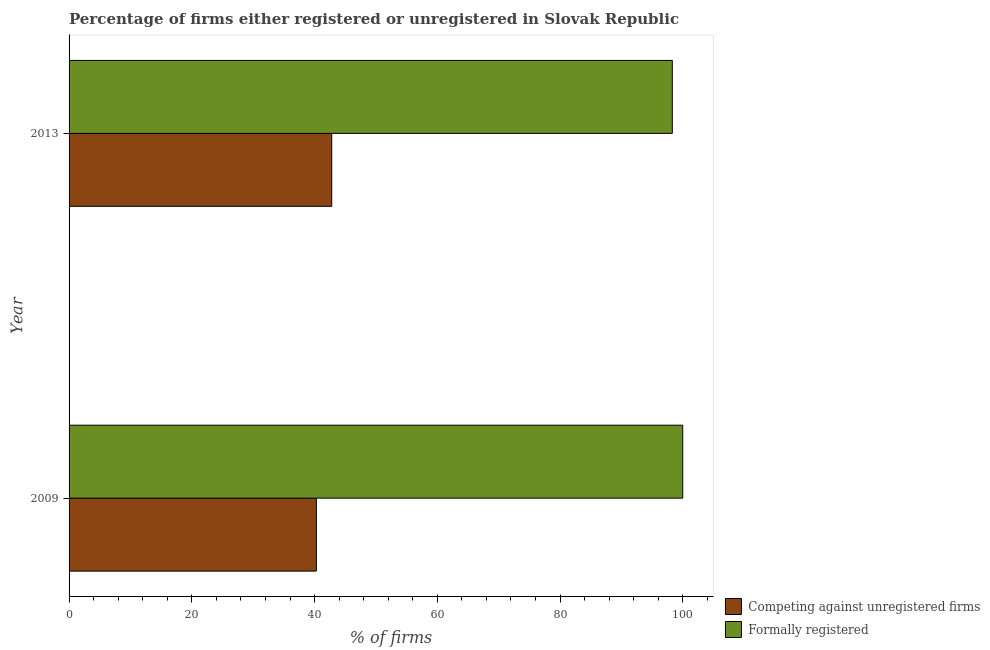How many different coloured bars are there?
Give a very brief answer. 2. How many groups of bars are there?
Offer a terse response. 2. In how many cases, is the number of bars for a given year not equal to the number of legend labels?
Provide a succinct answer. 0. What is the percentage of formally registered firms in 2009?
Your answer should be compact. 100. Across all years, what is the maximum percentage of formally registered firms?
Your response must be concise. 100. Across all years, what is the minimum percentage of formally registered firms?
Make the answer very short. 98.3. In which year was the percentage of registered firms maximum?
Ensure brevity in your answer.  2013. In which year was the percentage of registered firms minimum?
Keep it short and to the point. 2009. What is the total percentage of registered firms in the graph?
Your answer should be very brief. 83.1. What is the difference between the percentage of registered firms in 2009 and the percentage of formally registered firms in 2013?
Your answer should be compact. -58. What is the average percentage of formally registered firms per year?
Your answer should be compact. 99.15. In the year 2013, what is the difference between the percentage of registered firms and percentage of formally registered firms?
Your response must be concise. -55.5. Is the percentage of formally registered firms in 2009 less than that in 2013?
Your answer should be very brief. No. What does the 2nd bar from the top in 2009 represents?
Your answer should be compact. Competing against unregistered firms. What does the 1st bar from the bottom in 2009 represents?
Provide a short and direct response. Competing against unregistered firms. How many bars are there?
Ensure brevity in your answer.  4. Are all the bars in the graph horizontal?
Your answer should be compact. Yes. How many years are there in the graph?
Provide a succinct answer. 2. Are the values on the major ticks of X-axis written in scientific E-notation?
Your answer should be very brief. No. Does the graph contain any zero values?
Ensure brevity in your answer.  No. Does the graph contain grids?
Your answer should be compact. No. How many legend labels are there?
Offer a terse response. 2. How are the legend labels stacked?
Ensure brevity in your answer.  Vertical. What is the title of the graph?
Your answer should be very brief. Percentage of firms either registered or unregistered in Slovak Republic. Does "Forest" appear as one of the legend labels in the graph?
Provide a short and direct response. No. What is the label or title of the X-axis?
Make the answer very short. % of firms. What is the label or title of the Y-axis?
Provide a short and direct response. Year. What is the % of firms of Competing against unregistered firms in 2009?
Your answer should be very brief. 40.3. What is the % of firms in Competing against unregistered firms in 2013?
Keep it short and to the point. 42.8. What is the % of firms in Formally registered in 2013?
Offer a very short reply. 98.3. Across all years, what is the maximum % of firms of Competing against unregistered firms?
Keep it short and to the point. 42.8. Across all years, what is the maximum % of firms in Formally registered?
Provide a short and direct response. 100. Across all years, what is the minimum % of firms of Competing against unregistered firms?
Give a very brief answer. 40.3. Across all years, what is the minimum % of firms of Formally registered?
Keep it short and to the point. 98.3. What is the total % of firms in Competing against unregistered firms in the graph?
Offer a terse response. 83.1. What is the total % of firms in Formally registered in the graph?
Keep it short and to the point. 198.3. What is the difference between the % of firms of Formally registered in 2009 and that in 2013?
Ensure brevity in your answer.  1.7. What is the difference between the % of firms of Competing against unregistered firms in 2009 and the % of firms of Formally registered in 2013?
Offer a very short reply. -58. What is the average % of firms in Competing against unregistered firms per year?
Provide a succinct answer. 41.55. What is the average % of firms in Formally registered per year?
Make the answer very short. 99.15. In the year 2009, what is the difference between the % of firms of Competing against unregistered firms and % of firms of Formally registered?
Provide a short and direct response. -59.7. In the year 2013, what is the difference between the % of firms of Competing against unregistered firms and % of firms of Formally registered?
Your answer should be very brief. -55.5. What is the ratio of the % of firms in Competing against unregistered firms in 2009 to that in 2013?
Ensure brevity in your answer.  0.94. What is the ratio of the % of firms of Formally registered in 2009 to that in 2013?
Your answer should be very brief. 1.02. What is the difference between the highest and the second highest % of firms in Competing against unregistered firms?
Provide a succinct answer. 2.5. What is the difference between the highest and the second highest % of firms of Formally registered?
Provide a short and direct response. 1.7. What is the difference between the highest and the lowest % of firms in Formally registered?
Keep it short and to the point. 1.7. 